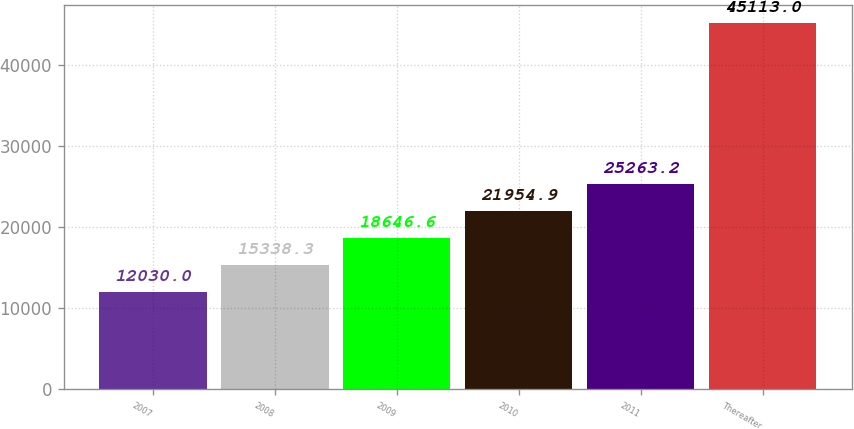<chart> <loc_0><loc_0><loc_500><loc_500><bar_chart><fcel>2007<fcel>2008<fcel>2009<fcel>2010<fcel>2011<fcel>Thereafter<nl><fcel>12030<fcel>15338.3<fcel>18646.6<fcel>21954.9<fcel>25263.2<fcel>45113<nl></chart> 